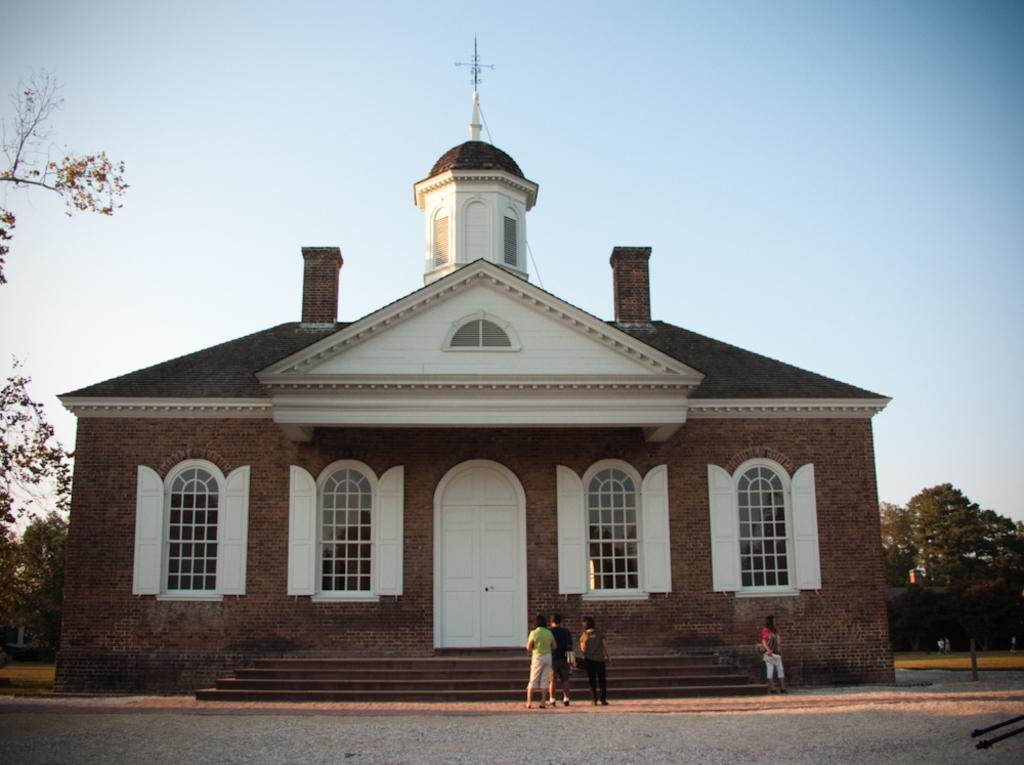In one or two sentences, can you explain what this image depicts? In this image I can see few people standing in-front of the house. I can see the windows to the house. In the background I can see many trees and the sky. 